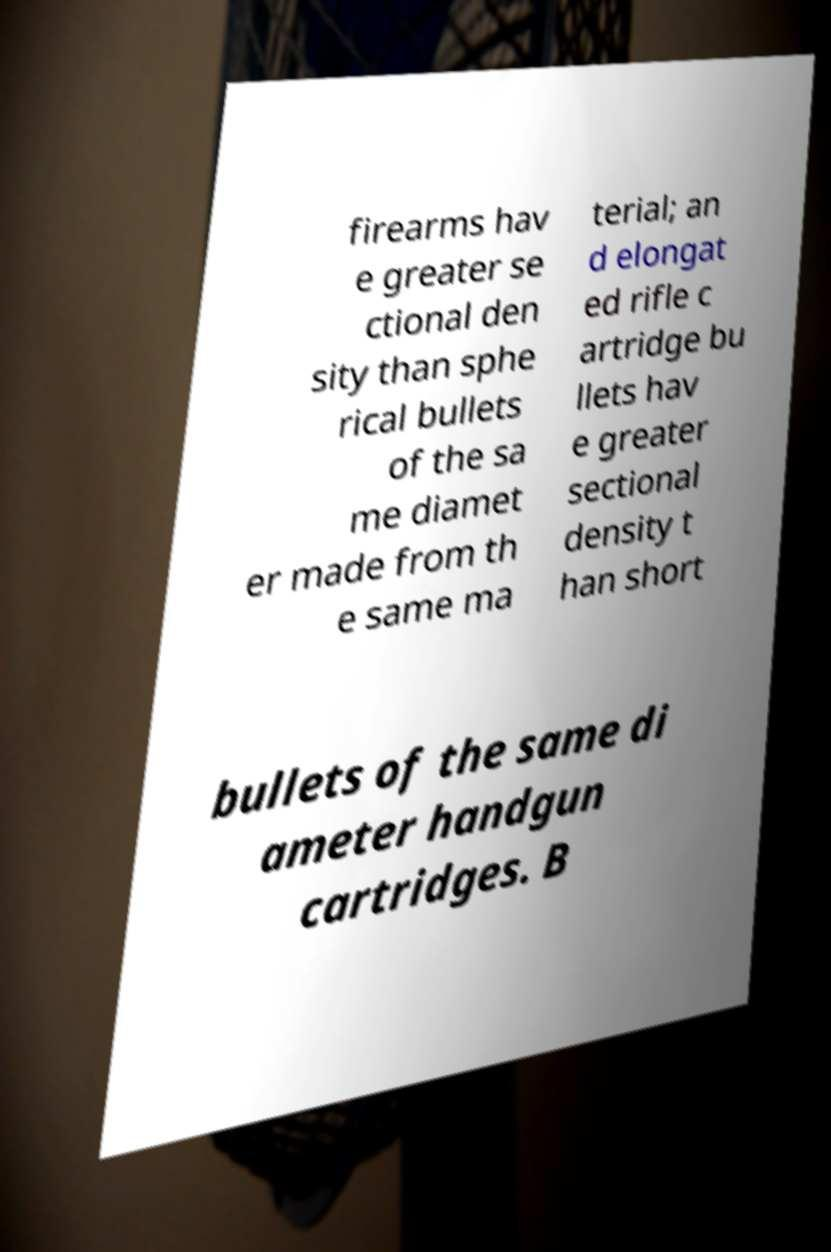There's text embedded in this image that I need extracted. Can you transcribe it verbatim? firearms hav e greater se ctional den sity than sphe rical bullets of the sa me diamet er made from th e same ma terial; an d elongat ed rifle c artridge bu llets hav e greater sectional density t han short bullets of the same di ameter handgun cartridges. B 